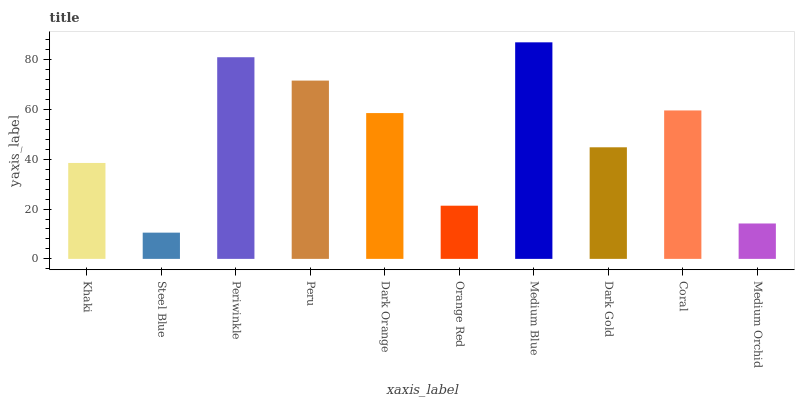Is Steel Blue the minimum?
Answer yes or no. Yes. Is Medium Blue the maximum?
Answer yes or no. Yes. Is Periwinkle the minimum?
Answer yes or no. No. Is Periwinkle the maximum?
Answer yes or no. No. Is Periwinkle greater than Steel Blue?
Answer yes or no. Yes. Is Steel Blue less than Periwinkle?
Answer yes or no. Yes. Is Steel Blue greater than Periwinkle?
Answer yes or no. No. Is Periwinkle less than Steel Blue?
Answer yes or no. No. Is Dark Orange the high median?
Answer yes or no. Yes. Is Dark Gold the low median?
Answer yes or no. Yes. Is Dark Gold the high median?
Answer yes or no. No. Is Periwinkle the low median?
Answer yes or no. No. 